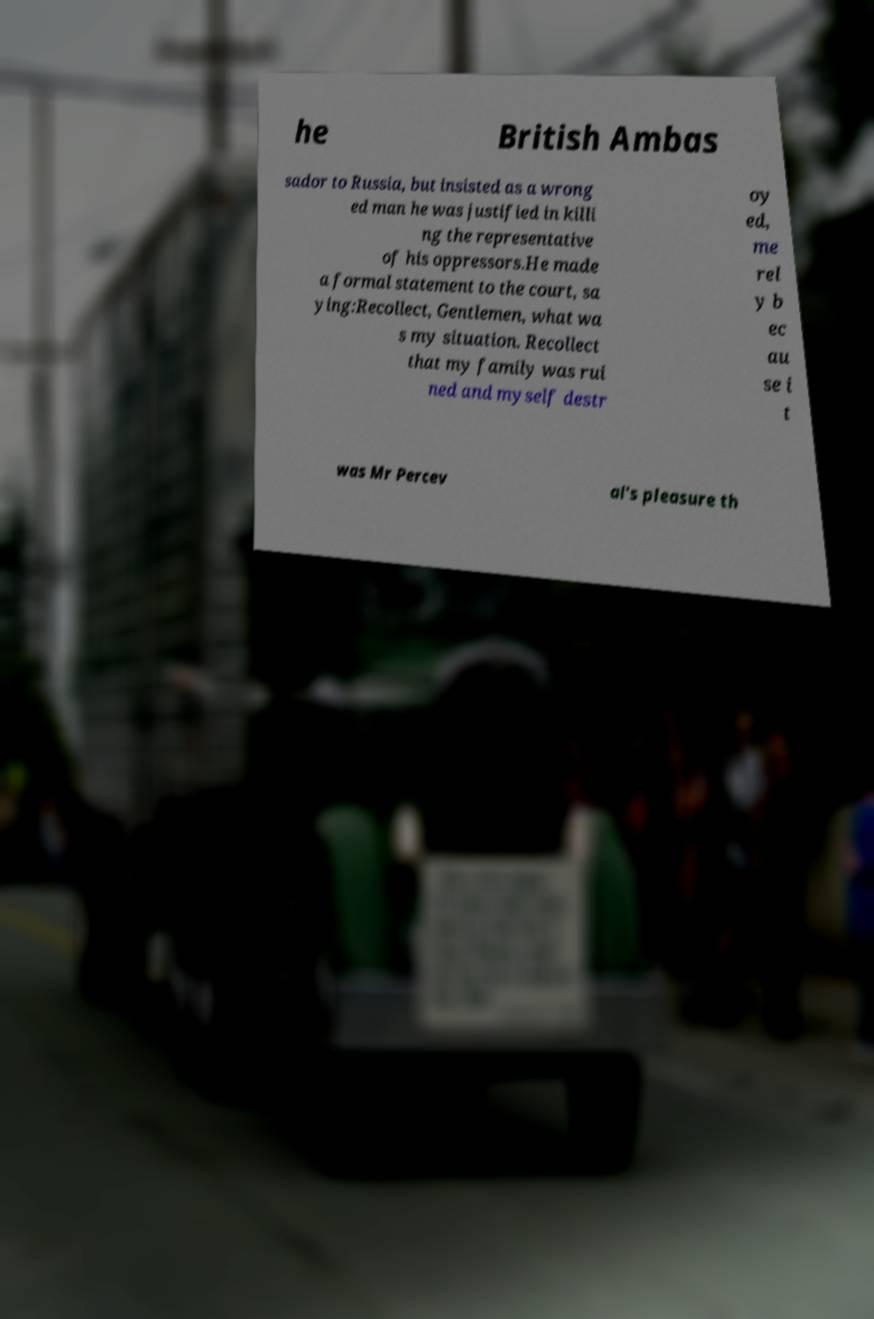Could you extract and type out the text from this image? he British Ambas sador to Russia, but insisted as a wrong ed man he was justified in killi ng the representative of his oppressors.He made a formal statement to the court, sa ying:Recollect, Gentlemen, what wa s my situation. Recollect that my family was rui ned and myself destr oy ed, me rel y b ec au se i t was Mr Percev al's pleasure th 